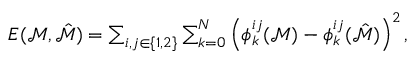Convert formula to latex. <formula><loc_0><loc_0><loc_500><loc_500>\begin{array} { r } { E ( \mathcal { M } , \hat { \mathcal { M } } ) = \sum _ { i , j \in \{ 1 , 2 \} } \sum _ { k = 0 } ^ { N } \left ( \phi _ { k } ^ { i j } ( \mathcal { M } ) - \phi _ { k } ^ { i j } ( \hat { \mathcal { M } } ) \right ) ^ { 2 } , } \end{array}</formula> 